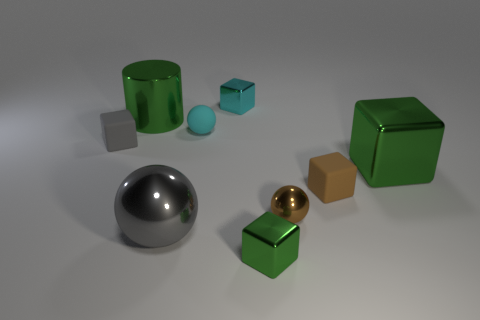Is there a big metal cylinder that has the same color as the big shiny block?
Give a very brief answer. Yes. How many things are tiny brown metal spheres or small cubes?
Ensure brevity in your answer.  5. What is the color of the shiny cube that is the same size as the green cylinder?
Your response must be concise. Green. What number of things are either large green metal things in front of the large cylinder or metal blocks that are in front of the gray cube?
Provide a succinct answer. 2. Is the number of gray metallic balls that are in front of the small green object the same as the number of brown matte blocks?
Your response must be concise. No. Do the metal sphere left of the cyan metal object and the matte thing in front of the small gray cube have the same size?
Your answer should be very brief. No. How many other things are the same size as the brown rubber block?
Your answer should be compact. 5. There is a big thing right of the tiny shiny thing that is behind the small brown metal thing; is there a gray metallic object that is in front of it?
Offer a terse response. Yes. Are there any other things that have the same color as the cylinder?
Offer a terse response. Yes. What size is the gray object that is behind the big green block?
Provide a succinct answer. Small. 